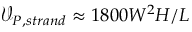<formula> <loc_0><loc_0><loc_500><loc_500>\mathcal { V } _ { P , s t r a n d } \approx 1 8 0 0 W ^ { 2 } H / L</formula> 